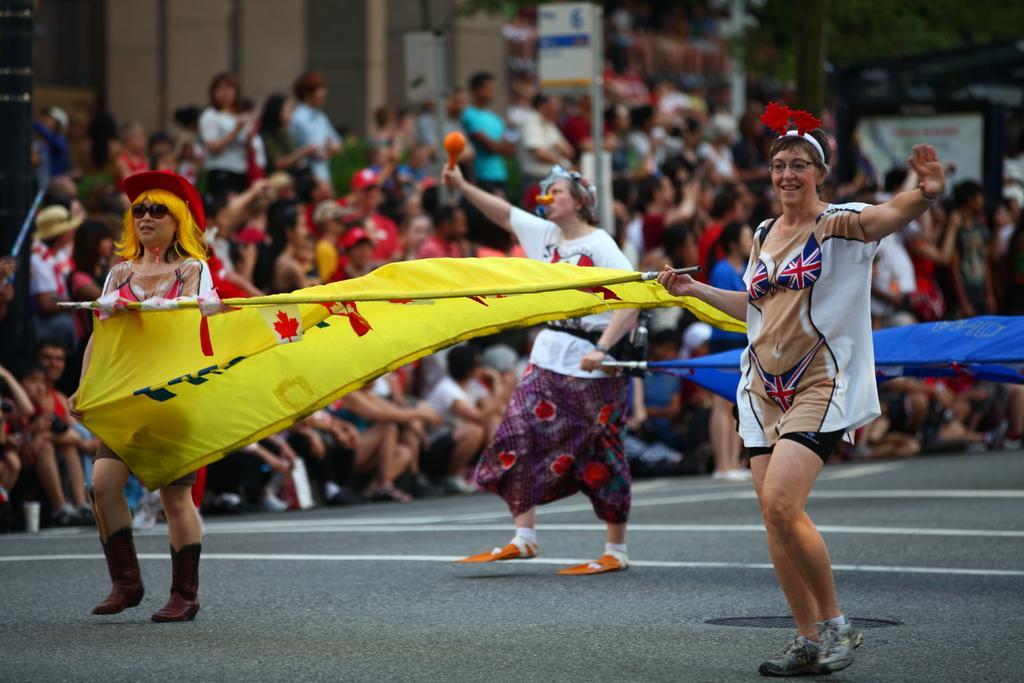How would you summarize this image in a sentence or two? In the image I can see some people walking on the road holding some flags, beside them there are so many people standing and sitting in-front of building. 